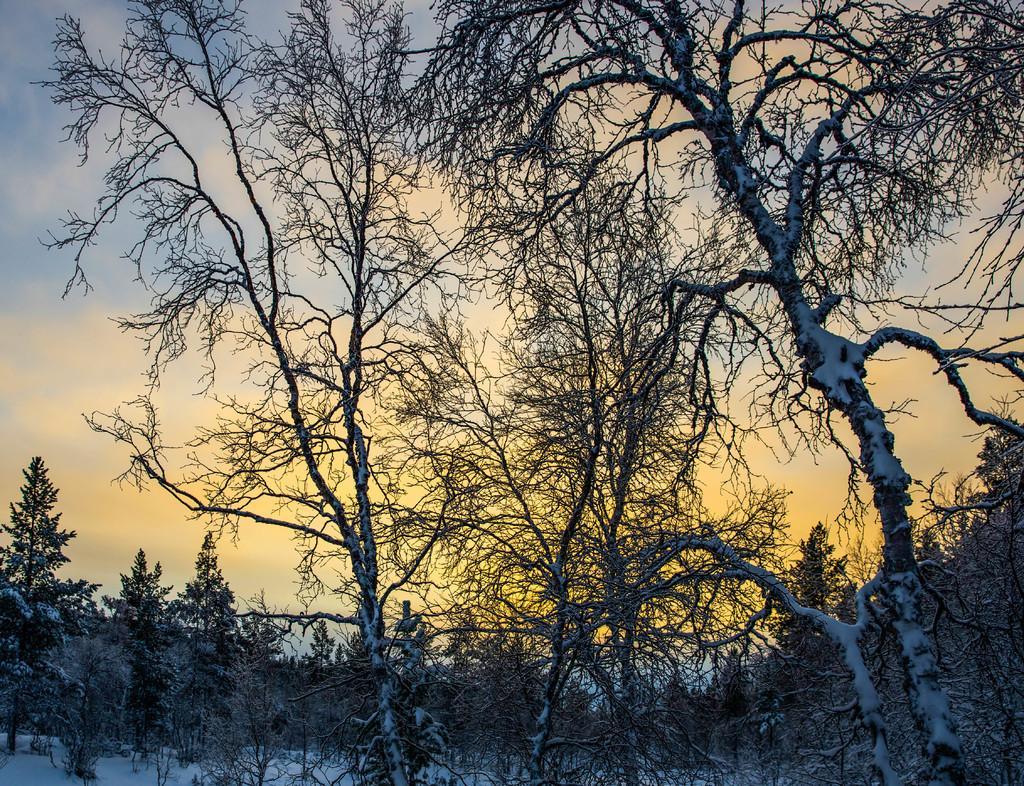Please provide a concise description of this image. In this picture we can see trees, snow and a sky. 